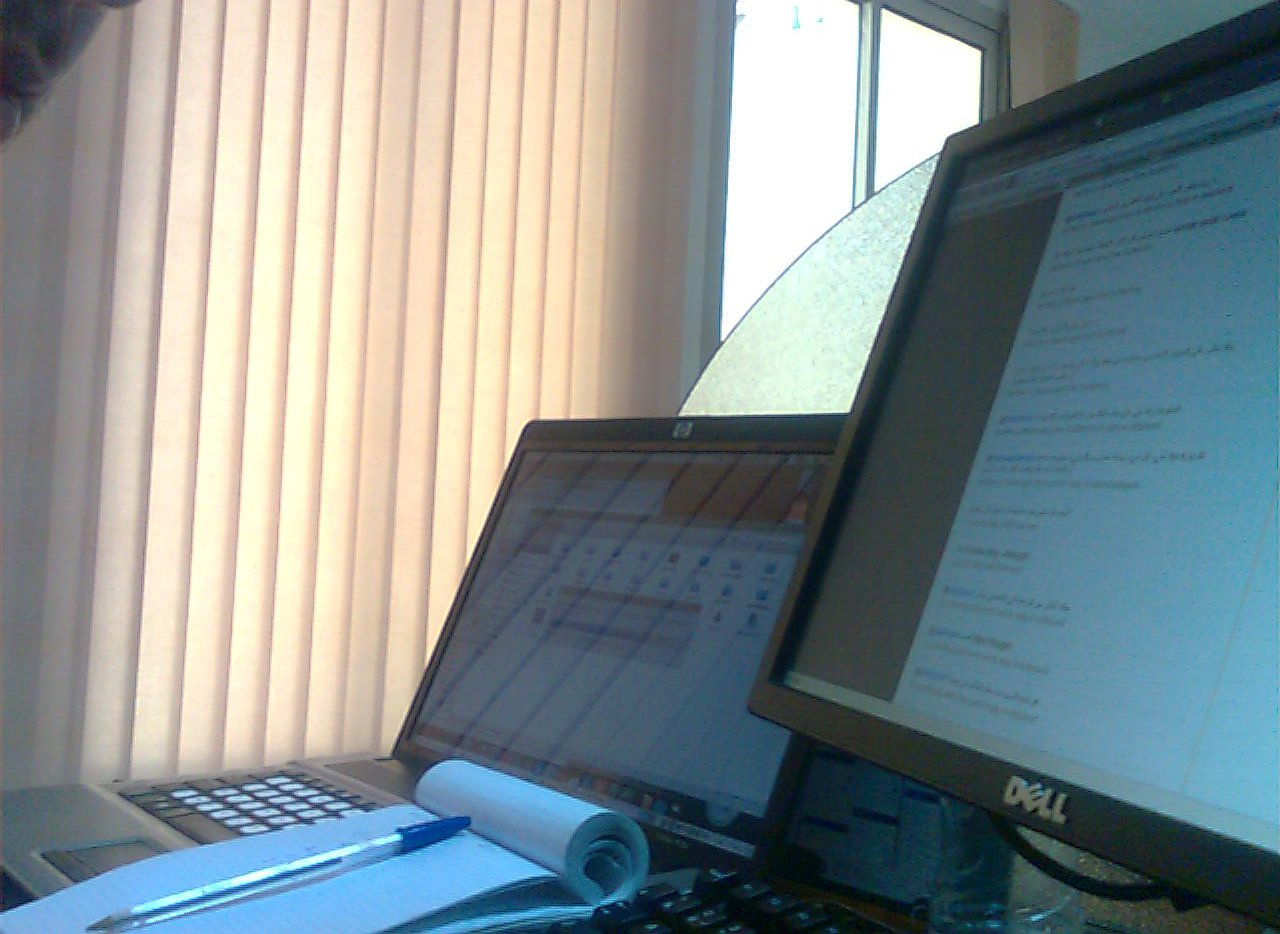What time of day does it look like outside the window? Based on the subdued lighting and the angle of the light streaming through the blinds, it appears to be either early morning or late afternoon. 